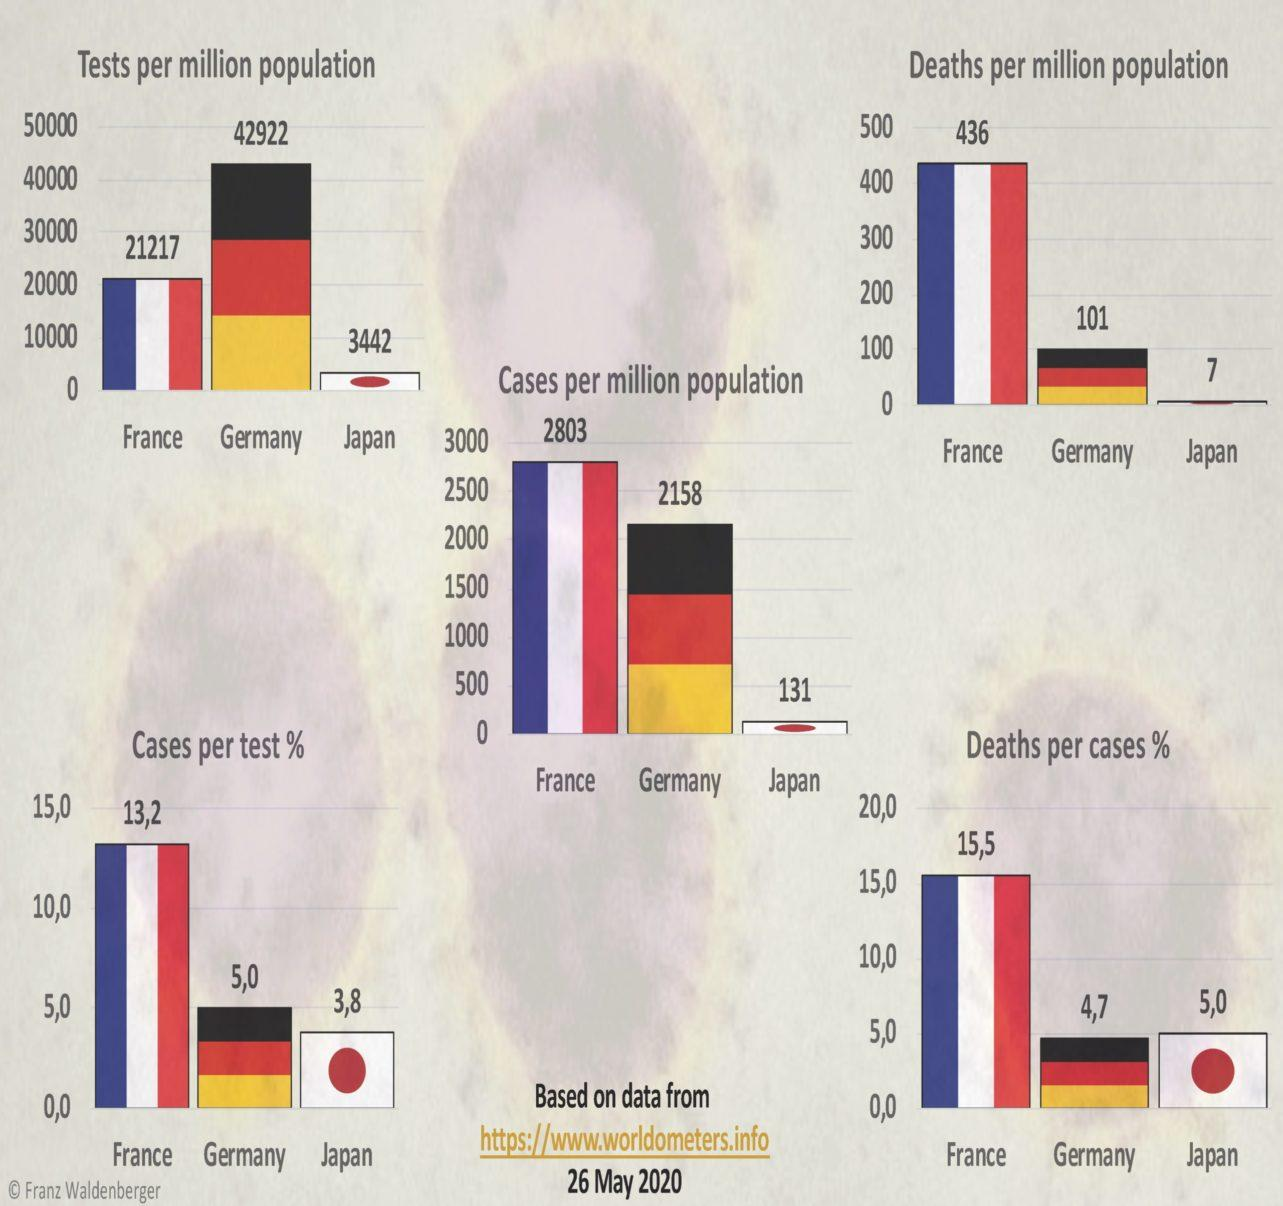Highlight a few significant elements in this photo. The number of deaths per million population in France is 335, whereas Germany has a higher number of deaths per million population at 459. In 2027, the number of cases per million population in Germany was higher than in Japan. The difference between the number of cases per million population in France and Germany is 645. There is a significant difference between the number of cases and deaths per million population in Germany, with cases averaging at 2057 and deaths per million population averaging at a lower number. 